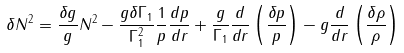<formula> <loc_0><loc_0><loc_500><loc_500>\delta N ^ { 2 } = \frac { \delta g } { g } N ^ { 2 } - \frac { g \delta \Gamma _ { 1 } } { \Gamma _ { 1 } ^ { 2 } } \frac { 1 } { p } \frac { d p } { d r } + \frac { g } { \Gamma _ { 1 } } \frac { d } { d r } \left ( \frac { \delta p } { p } \right ) - g \frac { d } { d r } \left ( \frac { \delta \rho } { \rho } \right )</formula> 